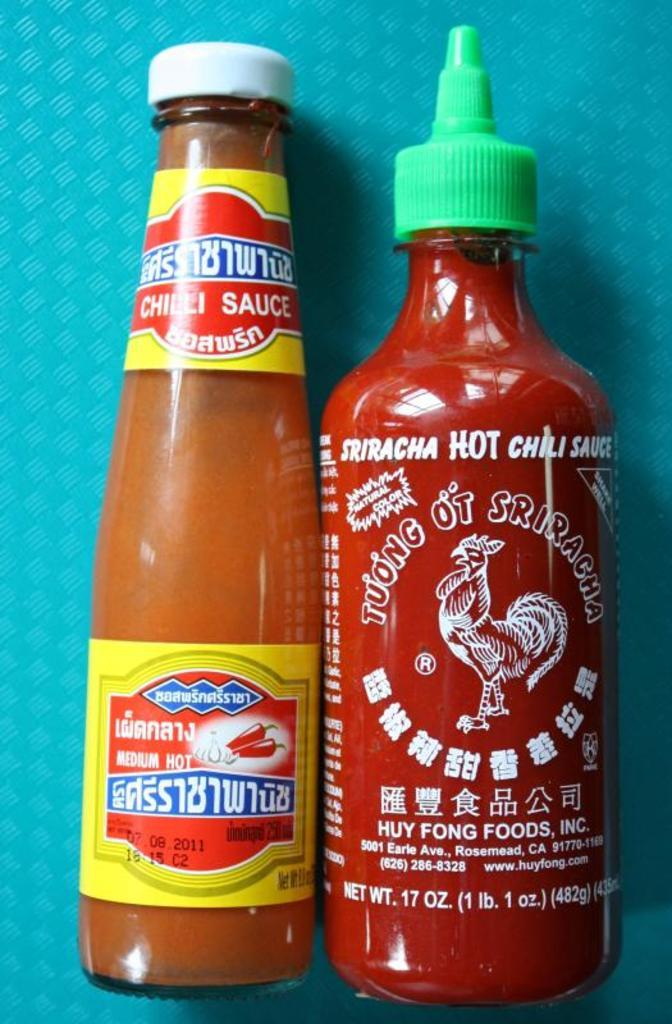Provide a one-sentence caption for the provided image. Bottle of chili sauce next to bottle of Sriracha hot chili sauce. 